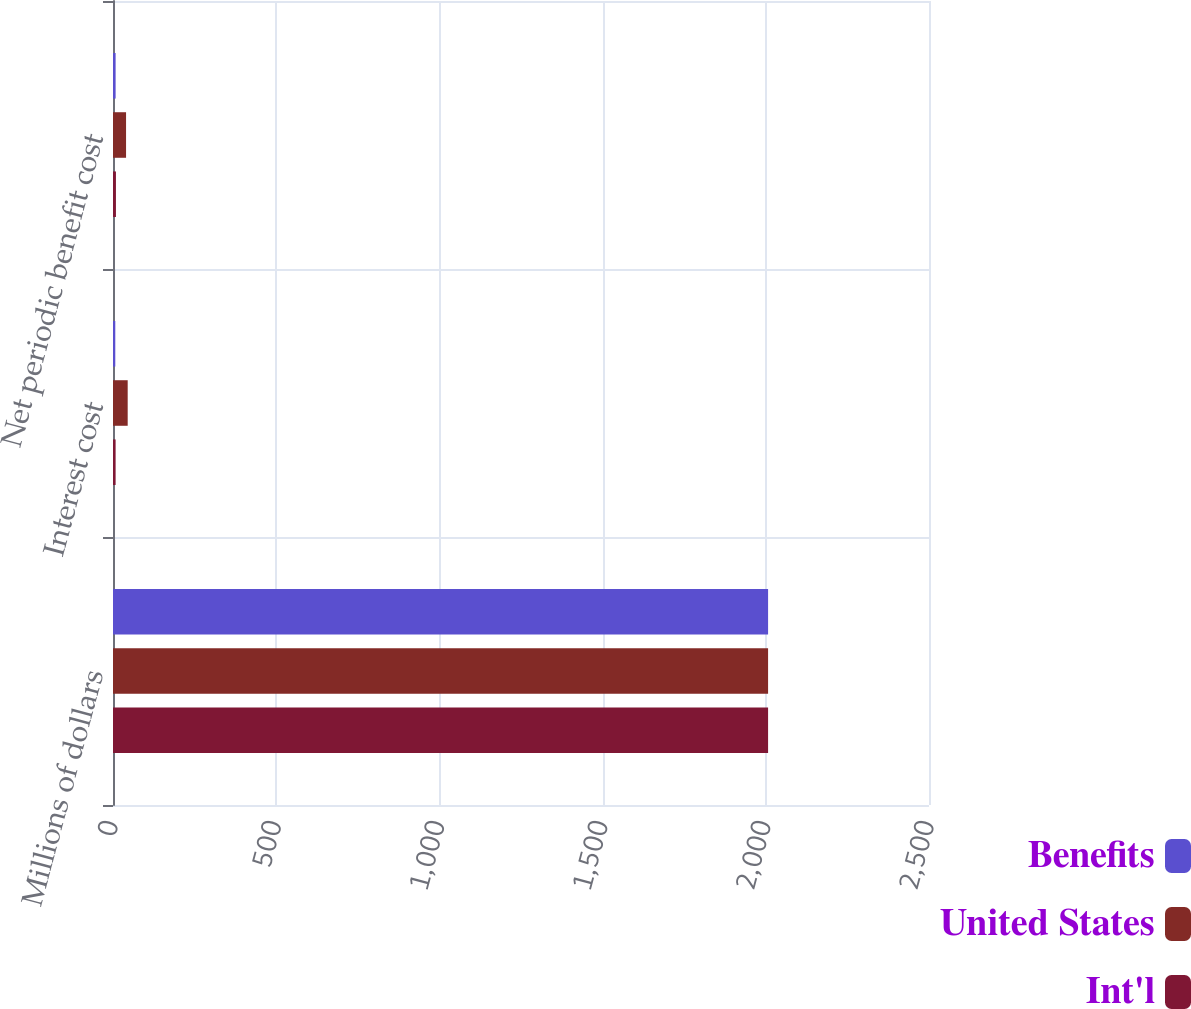Convert chart to OTSL. <chart><loc_0><loc_0><loc_500><loc_500><stacked_bar_chart><ecel><fcel>Millions of dollars<fcel>Interest cost<fcel>Net periodic benefit cost<nl><fcel>Benefits<fcel>2007<fcel>7<fcel>8<nl><fcel>United States<fcel>2007<fcel>45<fcel>40<nl><fcel>Int'l<fcel>2007<fcel>8<fcel>9<nl></chart> 